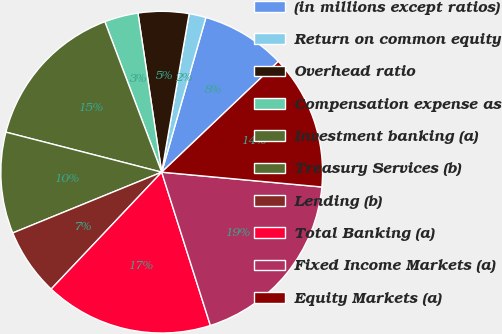Convert chart. <chart><loc_0><loc_0><loc_500><loc_500><pie_chart><fcel>(in millions except ratios)<fcel>Return on common equity<fcel>Overhead ratio<fcel>Compensation expense as<fcel>Investment banking (a)<fcel>Treasury Services (b)<fcel>Lending (b)<fcel>Total Banking (a)<fcel>Fixed Income Markets (a)<fcel>Equity Markets (a)<nl><fcel>8.48%<fcel>1.7%<fcel>5.09%<fcel>3.39%<fcel>15.25%<fcel>10.17%<fcel>6.78%<fcel>16.95%<fcel>18.64%<fcel>13.56%<nl></chart> 